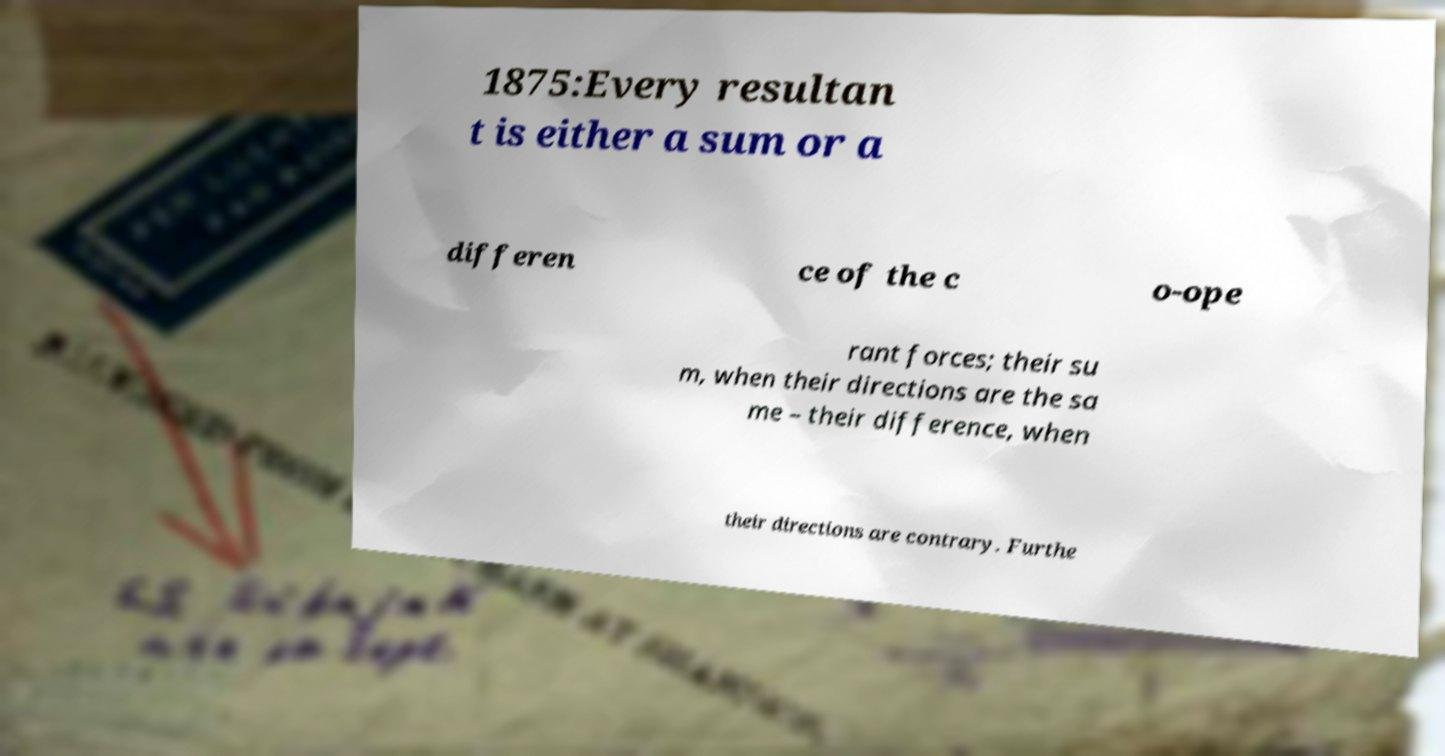There's text embedded in this image that I need extracted. Can you transcribe it verbatim? 1875:Every resultan t is either a sum or a differen ce of the c o-ope rant forces; their su m, when their directions are the sa me – their difference, when their directions are contrary. Furthe 